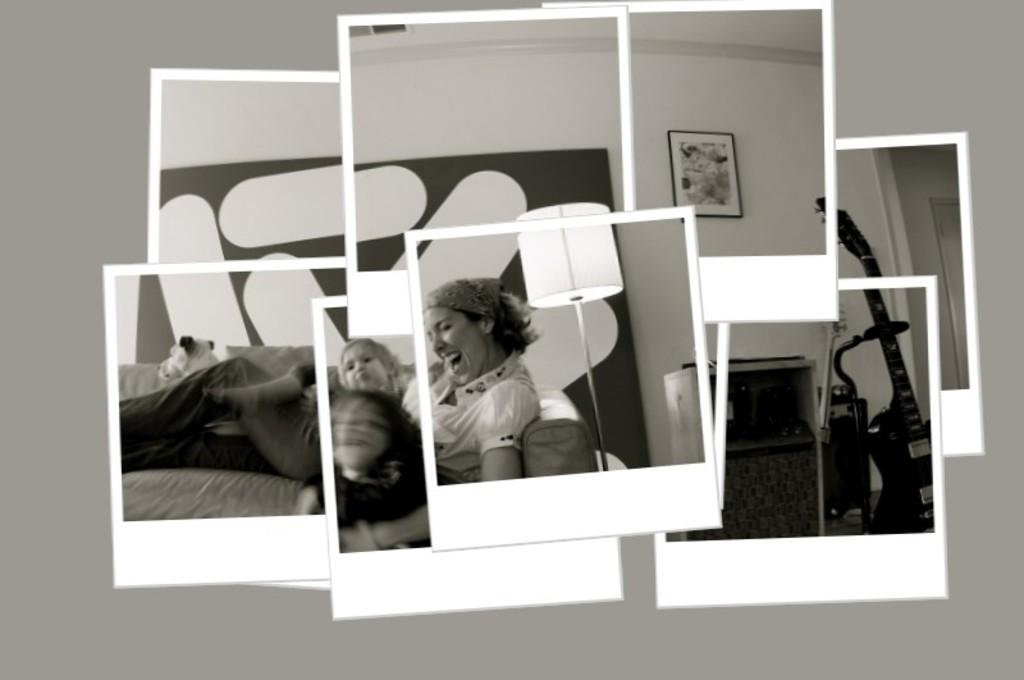What type of image is shown in the collage? The image is a collage of different images. Can you describe the background of the collage? There is a background visible in the image. How many friends are visible in the collage? There is no information about friends in the image, as it is a collage of different images and not focused on people. 